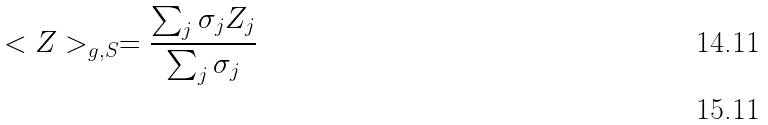Convert formula to latex. <formula><loc_0><loc_0><loc_500><loc_500>< Z > _ { g , S } = \frac { \sum _ { j } \sigma _ { j } Z _ { j } } { \sum _ { j } \sigma _ { j } } \\</formula> 